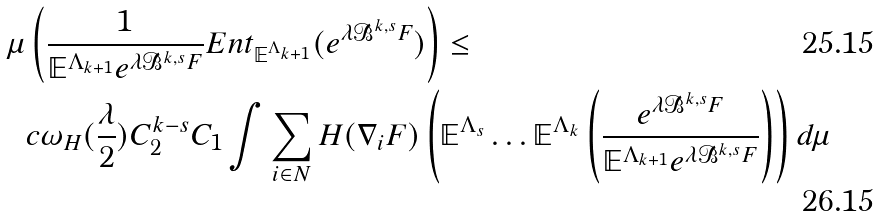Convert formula to latex. <formula><loc_0><loc_0><loc_500><loc_500>\mu & \left ( \frac { 1 } { \mathbb { E } ^ { \Lambda _ { k + 1 } } e ^ { \lambda \mathcal { B } ^ { k , s } F } } E n t _ { \mathbb { E } ^ { \Lambda _ { k + 1 } } } ( e ^ { \lambda \mathcal { B } ^ { k , s } F } ) \right ) \leq \\ & c \omega _ { H } ( \frac { \lambda } { 2 } ) C _ { 2 } ^ { k - s } C _ { 1 } \int \sum _ { i \in N } H ( \nabla _ { i } F ) \left ( \mathbb { E } ^ { \Lambda _ { s } } \dots \mathbb { E } ^ { \Lambda _ { k } } \left ( \frac { e ^ { \lambda \mathcal { B } ^ { k , s } F } } { \mathbb { E } ^ { \Lambda _ { k + 1 } } e ^ { \lambda \mathcal { B } ^ { k , s } F } } \right ) \right ) d \mu</formula> 